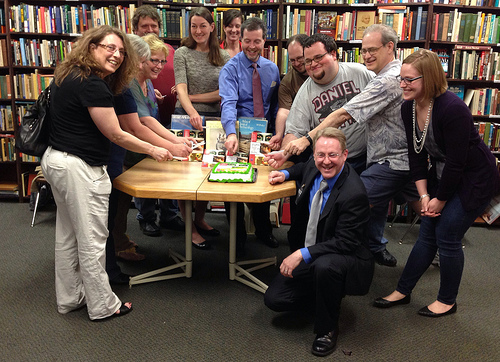<image>
Is the man next to the woman? No. The man is not positioned next to the woman. They are located in different areas of the scene. 